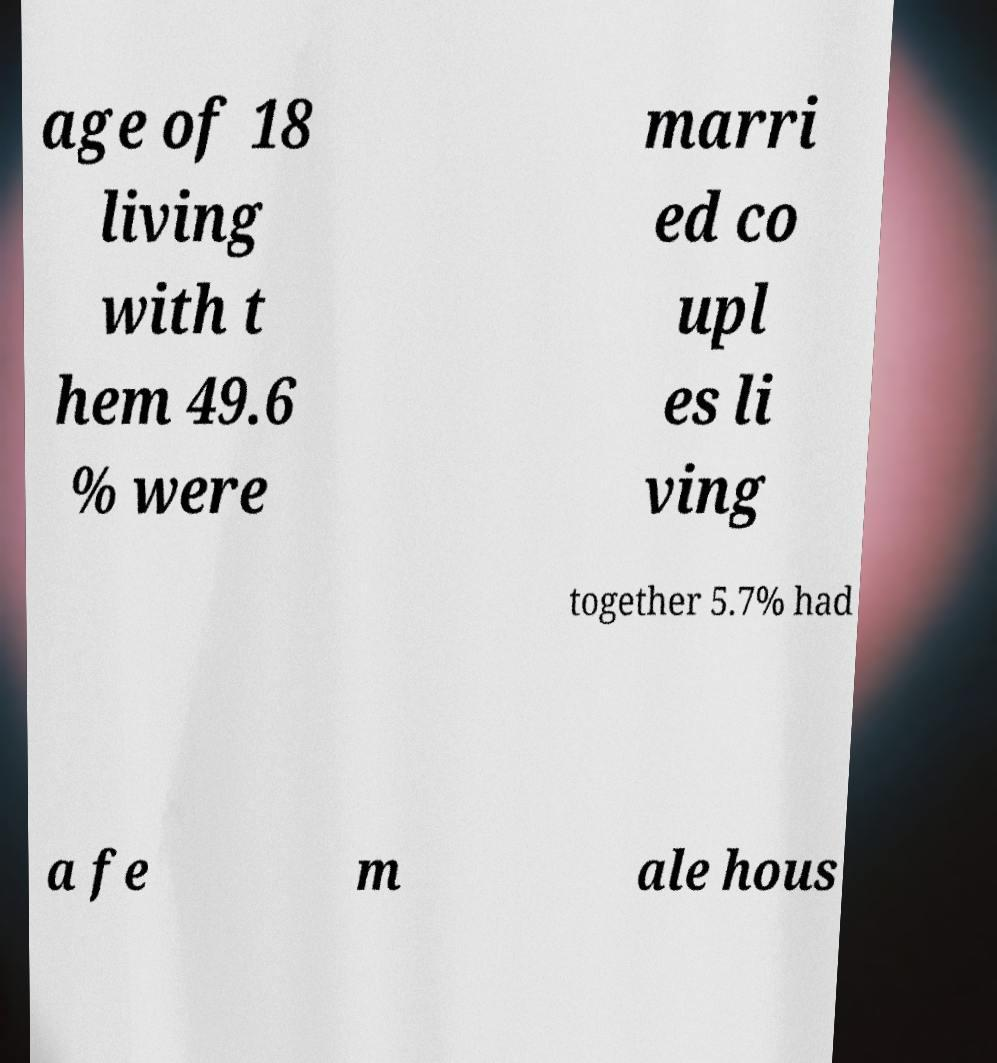Please read and relay the text visible in this image. What does it say? age of 18 living with t hem 49.6 % were marri ed co upl es li ving together 5.7% had a fe m ale hous 